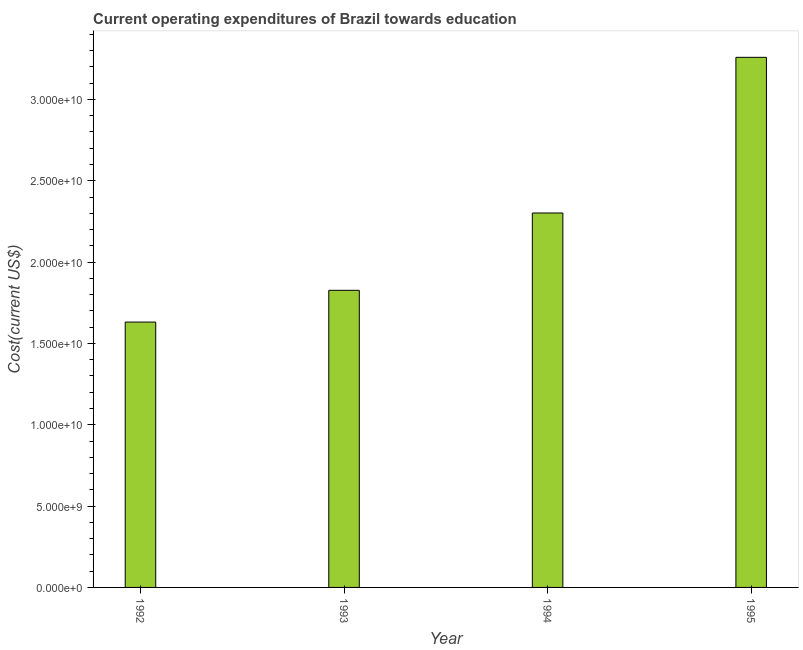Does the graph contain any zero values?
Make the answer very short. No. What is the title of the graph?
Keep it short and to the point. Current operating expenditures of Brazil towards education. What is the label or title of the X-axis?
Give a very brief answer. Year. What is the label or title of the Y-axis?
Keep it short and to the point. Cost(current US$). What is the education expenditure in 1994?
Offer a very short reply. 2.30e+1. Across all years, what is the maximum education expenditure?
Offer a very short reply. 3.26e+1. Across all years, what is the minimum education expenditure?
Ensure brevity in your answer.  1.63e+1. In which year was the education expenditure maximum?
Your response must be concise. 1995. What is the sum of the education expenditure?
Provide a succinct answer. 9.02e+1. What is the difference between the education expenditure in 1993 and 1995?
Your answer should be compact. -1.43e+1. What is the average education expenditure per year?
Ensure brevity in your answer.  2.25e+1. What is the median education expenditure?
Give a very brief answer. 2.06e+1. What is the ratio of the education expenditure in 1992 to that in 1995?
Ensure brevity in your answer.  0.5. Is the education expenditure in 1993 less than that in 1994?
Your answer should be very brief. Yes. What is the difference between the highest and the second highest education expenditure?
Give a very brief answer. 9.57e+09. What is the difference between the highest and the lowest education expenditure?
Offer a terse response. 1.63e+1. In how many years, is the education expenditure greater than the average education expenditure taken over all years?
Your answer should be compact. 2. Are all the bars in the graph horizontal?
Provide a succinct answer. No. How many years are there in the graph?
Provide a short and direct response. 4. Are the values on the major ticks of Y-axis written in scientific E-notation?
Offer a terse response. Yes. What is the Cost(current US$) of 1992?
Your response must be concise. 1.63e+1. What is the Cost(current US$) in 1993?
Ensure brevity in your answer.  1.83e+1. What is the Cost(current US$) in 1994?
Make the answer very short. 2.30e+1. What is the Cost(current US$) of 1995?
Offer a very short reply. 3.26e+1. What is the difference between the Cost(current US$) in 1992 and 1993?
Offer a terse response. -1.95e+09. What is the difference between the Cost(current US$) in 1992 and 1994?
Provide a short and direct response. -6.71e+09. What is the difference between the Cost(current US$) in 1992 and 1995?
Give a very brief answer. -1.63e+1. What is the difference between the Cost(current US$) in 1993 and 1994?
Your response must be concise. -4.75e+09. What is the difference between the Cost(current US$) in 1993 and 1995?
Provide a succinct answer. -1.43e+1. What is the difference between the Cost(current US$) in 1994 and 1995?
Provide a succinct answer. -9.57e+09. What is the ratio of the Cost(current US$) in 1992 to that in 1993?
Make the answer very short. 0.89. What is the ratio of the Cost(current US$) in 1992 to that in 1994?
Ensure brevity in your answer.  0.71. What is the ratio of the Cost(current US$) in 1992 to that in 1995?
Your response must be concise. 0.5. What is the ratio of the Cost(current US$) in 1993 to that in 1994?
Keep it short and to the point. 0.79. What is the ratio of the Cost(current US$) in 1993 to that in 1995?
Give a very brief answer. 0.56. What is the ratio of the Cost(current US$) in 1994 to that in 1995?
Your response must be concise. 0.71. 